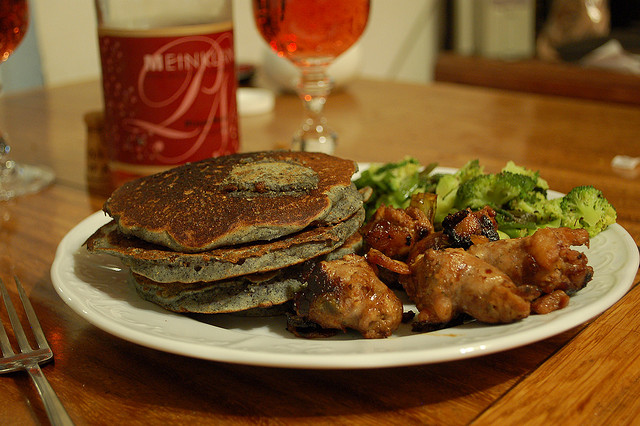<image>What kind of food is this? I don't know what kind of food is this. It could be chicken, pancakes broccoli chicken, or it could be some sort of dinner. What is she drinking? I don't know what she is drinking. It could be wine or sparkling wine. What kind of food is this? The type of food in the image is unknown. It can be Chinese food, chicken, or dinner. What is she drinking? I don't know what she is drinking. It seems like she is drinking wine. 